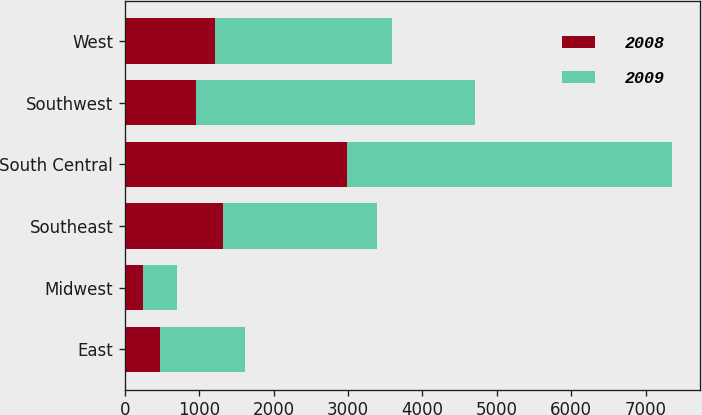Convert chart. <chart><loc_0><loc_0><loc_500><loc_500><stacked_bar_chart><ecel><fcel>East<fcel>Midwest<fcel>Southeast<fcel>South Central<fcel>Southwest<fcel>West<nl><fcel>2008<fcel>478<fcel>240<fcel>1321<fcel>2980<fcel>962<fcel>1207<nl><fcel>2009<fcel>1138<fcel>464<fcel>2069<fcel>4381<fcel>3742<fcel>2378<nl></chart> 